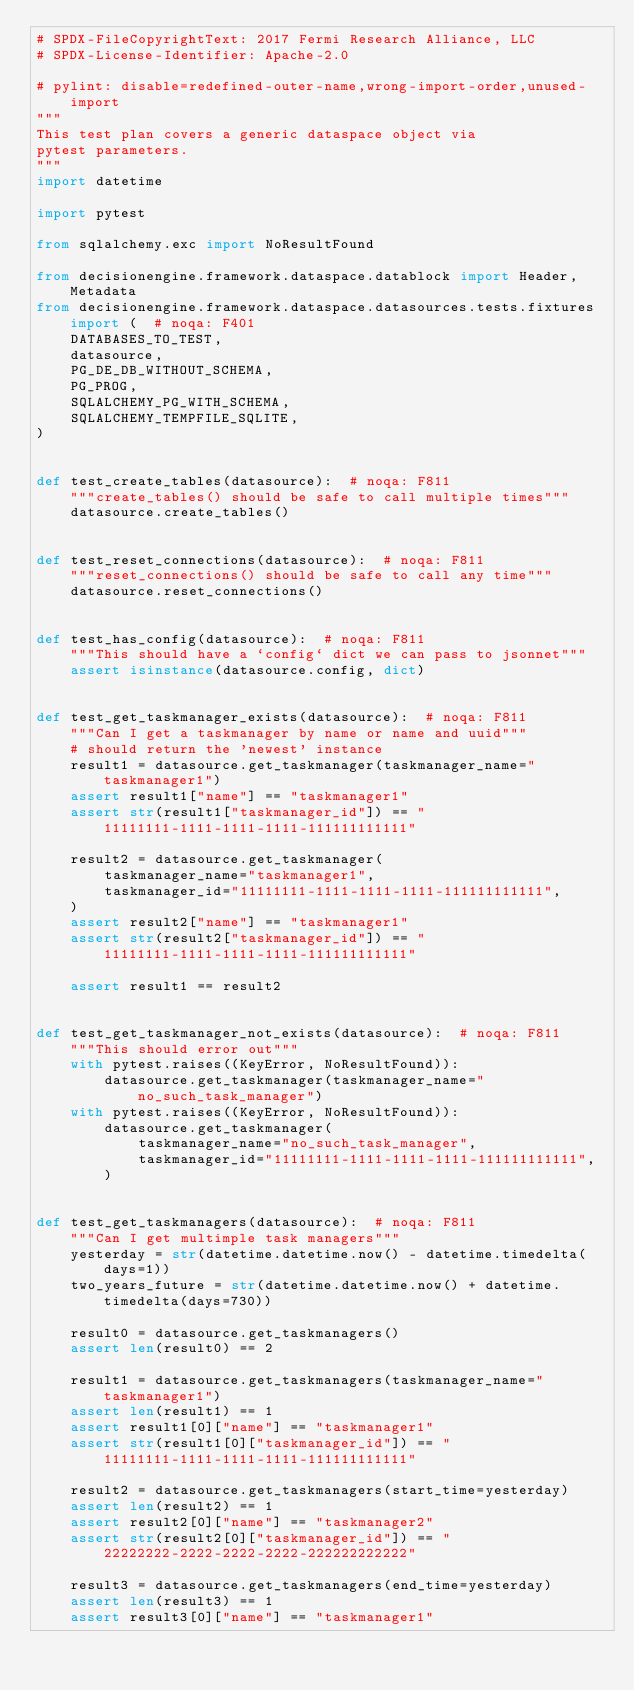Convert code to text. <code><loc_0><loc_0><loc_500><loc_500><_Python_># SPDX-FileCopyrightText: 2017 Fermi Research Alliance, LLC
# SPDX-License-Identifier: Apache-2.0

# pylint: disable=redefined-outer-name,wrong-import-order,unused-import
"""
This test plan covers a generic dataspace object via
pytest parameters.
"""
import datetime

import pytest

from sqlalchemy.exc import NoResultFound

from decisionengine.framework.dataspace.datablock import Header, Metadata
from decisionengine.framework.dataspace.datasources.tests.fixtures import (  # noqa: F401
    DATABASES_TO_TEST,
    datasource,
    PG_DE_DB_WITHOUT_SCHEMA,
    PG_PROG,
    SQLALCHEMY_PG_WITH_SCHEMA,
    SQLALCHEMY_TEMPFILE_SQLITE,
)


def test_create_tables(datasource):  # noqa: F811
    """create_tables() should be safe to call multiple times"""
    datasource.create_tables()


def test_reset_connections(datasource):  # noqa: F811
    """reset_connections() should be safe to call any time"""
    datasource.reset_connections()


def test_has_config(datasource):  # noqa: F811
    """This should have a `config` dict we can pass to jsonnet"""
    assert isinstance(datasource.config, dict)


def test_get_taskmanager_exists(datasource):  # noqa: F811
    """Can I get a taskmanager by name or name and uuid"""
    # should return the 'newest' instance
    result1 = datasource.get_taskmanager(taskmanager_name="taskmanager1")
    assert result1["name"] == "taskmanager1"
    assert str(result1["taskmanager_id"]) == "11111111-1111-1111-1111-111111111111"

    result2 = datasource.get_taskmanager(
        taskmanager_name="taskmanager1",
        taskmanager_id="11111111-1111-1111-1111-111111111111",
    )
    assert result2["name"] == "taskmanager1"
    assert str(result2["taskmanager_id"]) == "11111111-1111-1111-1111-111111111111"

    assert result1 == result2


def test_get_taskmanager_not_exists(datasource):  # noqa: F811
    """This should error out"""
    with pytest.raises((KeyError, NoResultFound)):
        datasource.get_taskmanager(taskmanager_name="no_such_task_manager")
    with pytest.raises((KeyError, NoResultFound)):
        datasource.get_taskmanager(
            taskmanager_name="no_such_task_manager",
            taskmanager_id="11111111-1111-1111-1111-111111111111",
        )


def test_get_taskmanagers(datasource):  # noqa: F811
    """Can I get multimple task managers"""
    yesterday = str(datetime.datetime.now() - datetime.timedelta(days=1))
    two_years_future = str(datetime.datetime.now() + datetime.timedelta(days=730))

    result0 = datasource.get_taskmanagers()
    assert len(result0) == 2

    result1 = datasource.get_taskmanagers(taskmanager_name="taskmanager1")
    assert len(result1) == 1
    assert result1[0]["name"] == "taskmanager1"
    assert str(result1[0]["taskmanager_id"]) == "11111111-1111-1111-1111-111111111111"

    result2 = datasource.get_taskmanagers(start_time=yesterday)
    assert len(result2) == 1
    assert result2[0]["name"] == "taskmanager2"
    assert str(result2[0]["taskmanager_id"]) == "22222222-2222-2222-2222-222222222222"

    result3 = datasource.get_taskmanagers(end_time=yesterday)
    assert len(result3) == 1
    assert result3[0]["name"] == "taskmanager1"</code> 